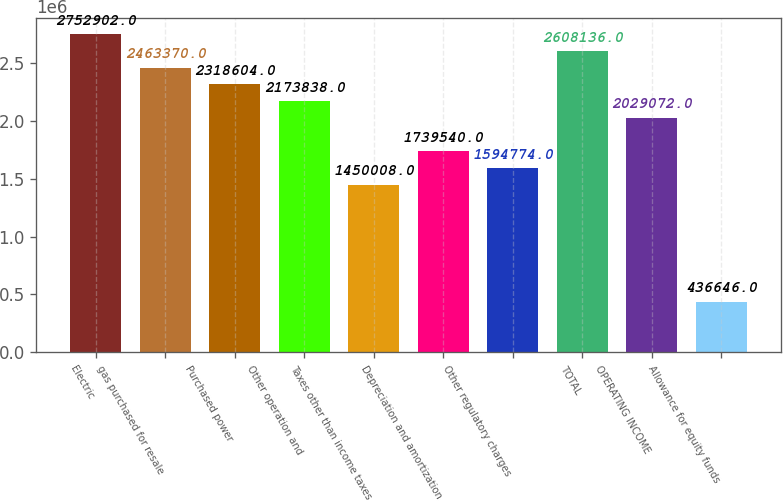<chart> <loc_0><loc_0><loc_500><loc_500><bar_chart><fcel>Electric<fcel>gas purchased for resale<fcel>Purchased power<fcel>Other operation and<fcel>Taxes other than income taxes<fcel>Depreciation and amortization<fcel>Other regulatory charges<fcel>TOTAL<fcel>OPERATING INCOME<fcel>Allowance for equity funds<nl><fcel>2.7529e+06<fcel>2.46337e+06<fcel>2.3186e+06<fcel>2.17384e+06<fcel>1.45001e+06<fcel>1.73954e+06<fcel>1.59477e+06<fcel>2.60814e+06<fcel>2.02907e+06<fcel>436646<nl></chart> 